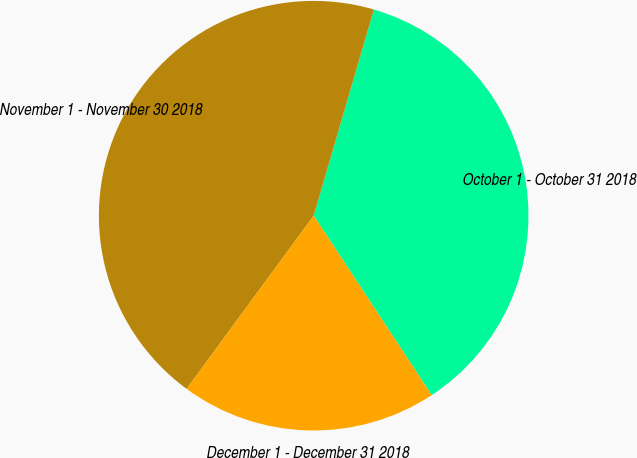<chart> <loc_0><loc_0><loc_500><loc_500><pie_chart><fcel>October 1 - October 31 2018<fcel>November 1 - November 30 2018<fcel>December 1 - December 31 2018<nl><fcel>36.22%<fcel>44.44%<fcel>19.33%<nl></chart> 